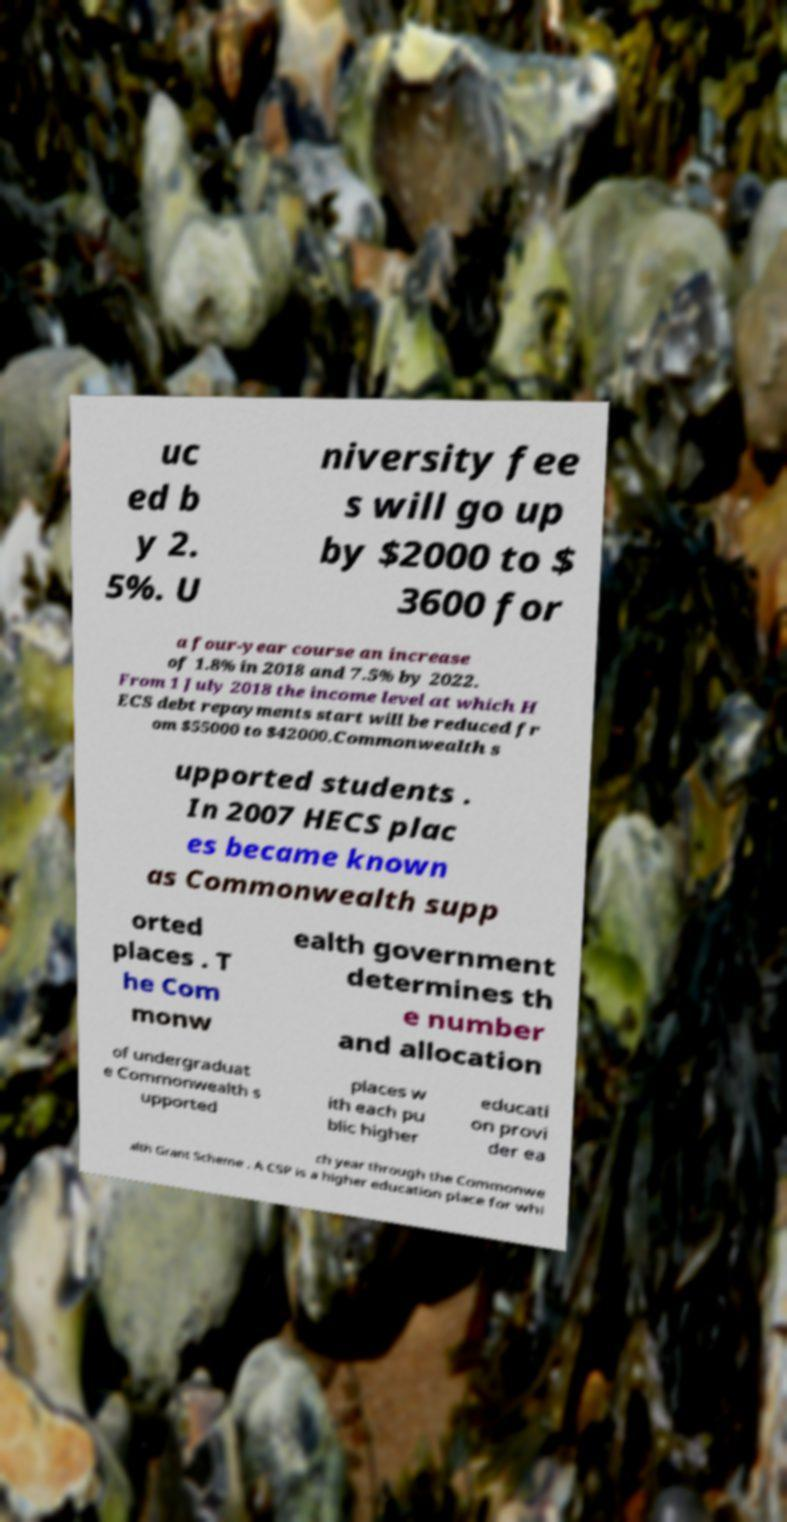Can you read and provide the text displayed in the image?This photo seems to have some interesting text. Can you extract and type it out for me? uc ed b y 2. 5%. U niversity fee s will go up by $2000 to $ 3600 for a four-year course an increase of 1.8% in 2018 and 7.5% by 2022. From 1 July 2018 the income level at which H ECS debt repayments start will be reduced fr om $55000 to $42000.Commonwealth s upported students . In 2007 HECS plac es became known as Commonwealth supp orted places . T he Com monw ealth government determines th e number and allocation of undergraduat e Commonwealth s upported places w ith each pu blic higher educati on provi der ea ch year through the Commonwe alth Grant Scheme . A CSP is a higher education place for whi 